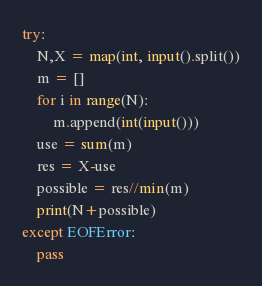<code> <loc_0><loc_0><loc_500><loc_500><_Python_>try:
    N,X = map(int, input().split())
    m = []
    for i in range(N):
        m.append(int(input()))
    use = sum(m)
    res = X-use
    possible = res//min(m)
    print(N+possible)
except EOFError:
    pass</code> 